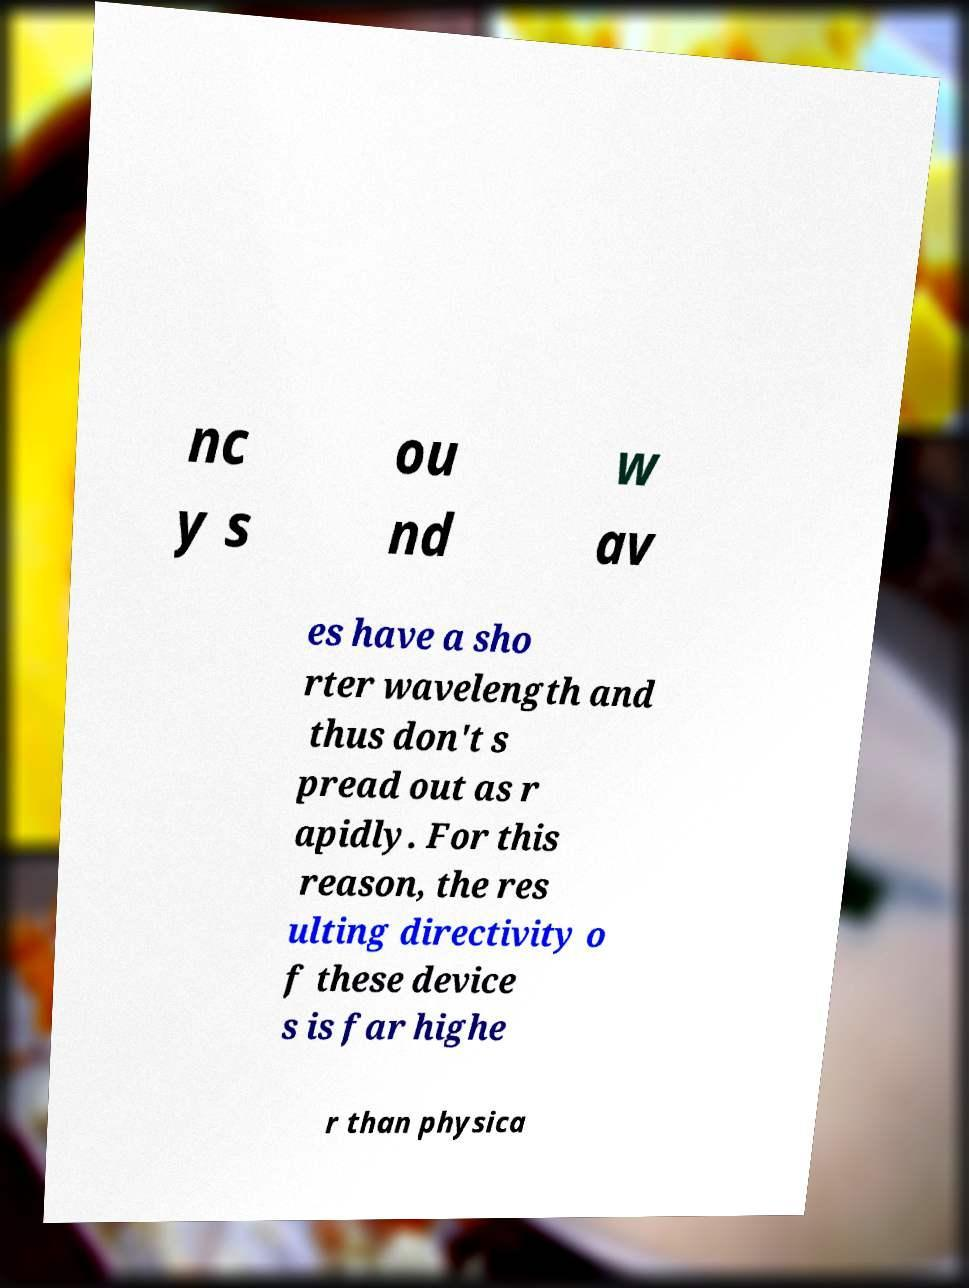What messages or text are displayed in this image? I need them in a readable, typed format. nc y s ou nd w av es have a sho rter wavelength and thus don't s pread out as r apidly. For this reason, the res ulting directivity o f these device s is far highe r than physica 